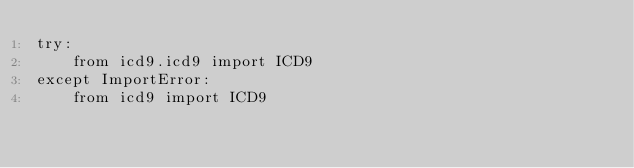Convert code to text. <code><loc_0><loc_0><loc_500><loc_500><_Python_>try:
    from icd9.icd9 import ICD9
except ImportError:
    from icd9 import ICD9
</code> 